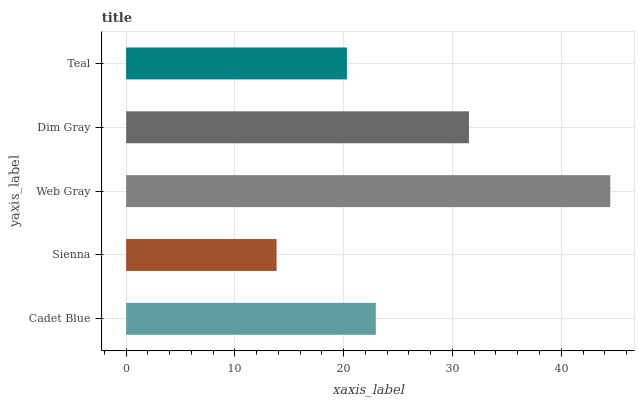Is Sienna the minimum?
Answer yes or no. Yes. Is Web Gray the maximum?
Answer yes or no. Yes. Is Web Gray the minimum?
Answer yes or no. No. Is Sienna the maximum?
Answer yes or no. No. Is Web Gray greater than Sienna?
Answer yes or no. Yes. Is Sienna less than Web Gray?
Answer yes or no. Yes. Is Sienna greater than Web Gray?
Answer yes or no. No. Is Web Gray less than Sienna?
Answer yes or no. No. Is Cadet Blue the high median?
Answer yes or no. Yes. Is Cadet Blue the low median?
Answer yes or no. Yes. Is Web Gray the high median?
Answer yes or no. No. Is Sienna the low median?
Answer yes or no. No. 